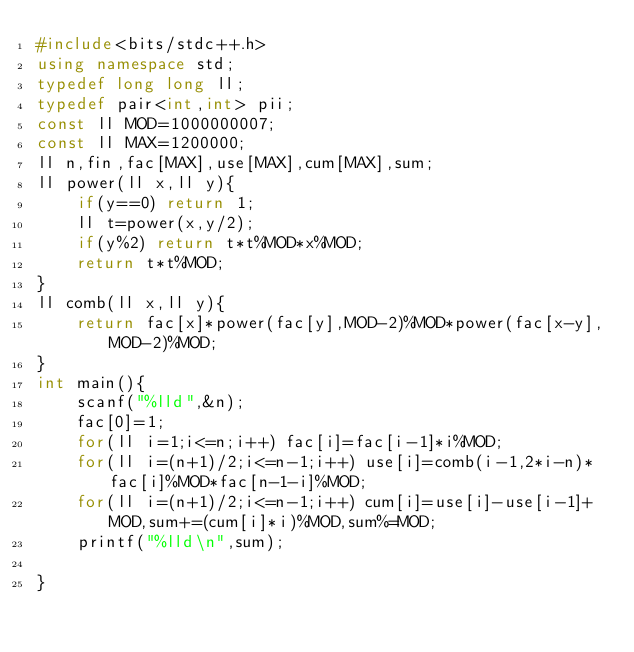<code> <loc_0><loc_0><loc_500><loc_500><_C++_>#include<bits/stdc++.h>
using namespace std;
typedef long long ll;
typedef pair<int,int> pii;
const ll MOD=1000000007;
const ll MAX=1200000;
ll n,fin,fac[MAX],use[MAX],cum[MAX],sum;
ll power(ll x,ll y){
    if(y==0) return 1;
    ll t=power(x,y/2);
    if(y%2) return t*t%MOD*x%MOD;
    return t*t%MOD;
}
ll comb(ll x,ll y){
    return fac[x]*power(fac[y],MOD-2)%MOD*power(fac[x-y],MOD-2)%MOD;
}
int main(){
    scanf("%lld",&n);
    fac[0]=1;
    for(ll i=1;i<=n;i++) fac[i]=fac[i-1]*i%MOD;
    for(ll i=(n+1)/2;i<=n-1;i++) use[i]=comb(i-1,2*i-n)*fac[i]%MOD*fac[n-1-i]%MOD;
    for(ll i=(n+1)/2;i<=n-1;i++) cum[i]=use[i]-use[i-1]+MOD,sum+=(cum[i]*i)%MOD,sum%=MOD;
    printf("%lld\n",sum);

}
</code> 